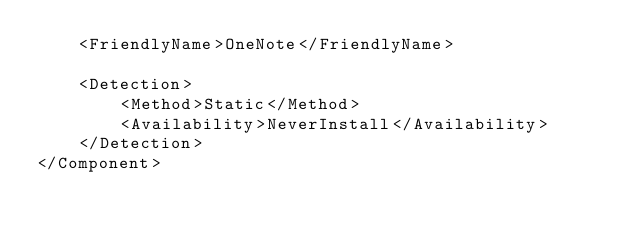<code> <loc_0><loc_0><loc_500><loc_500><_XML_>    <FriendlyName>OneNote</FriendlyName>

    <Detection>
        <Method>Static</Method>
        <Availability>NeverInstall</Availability>
    </Detection>
</Component>
</code> 